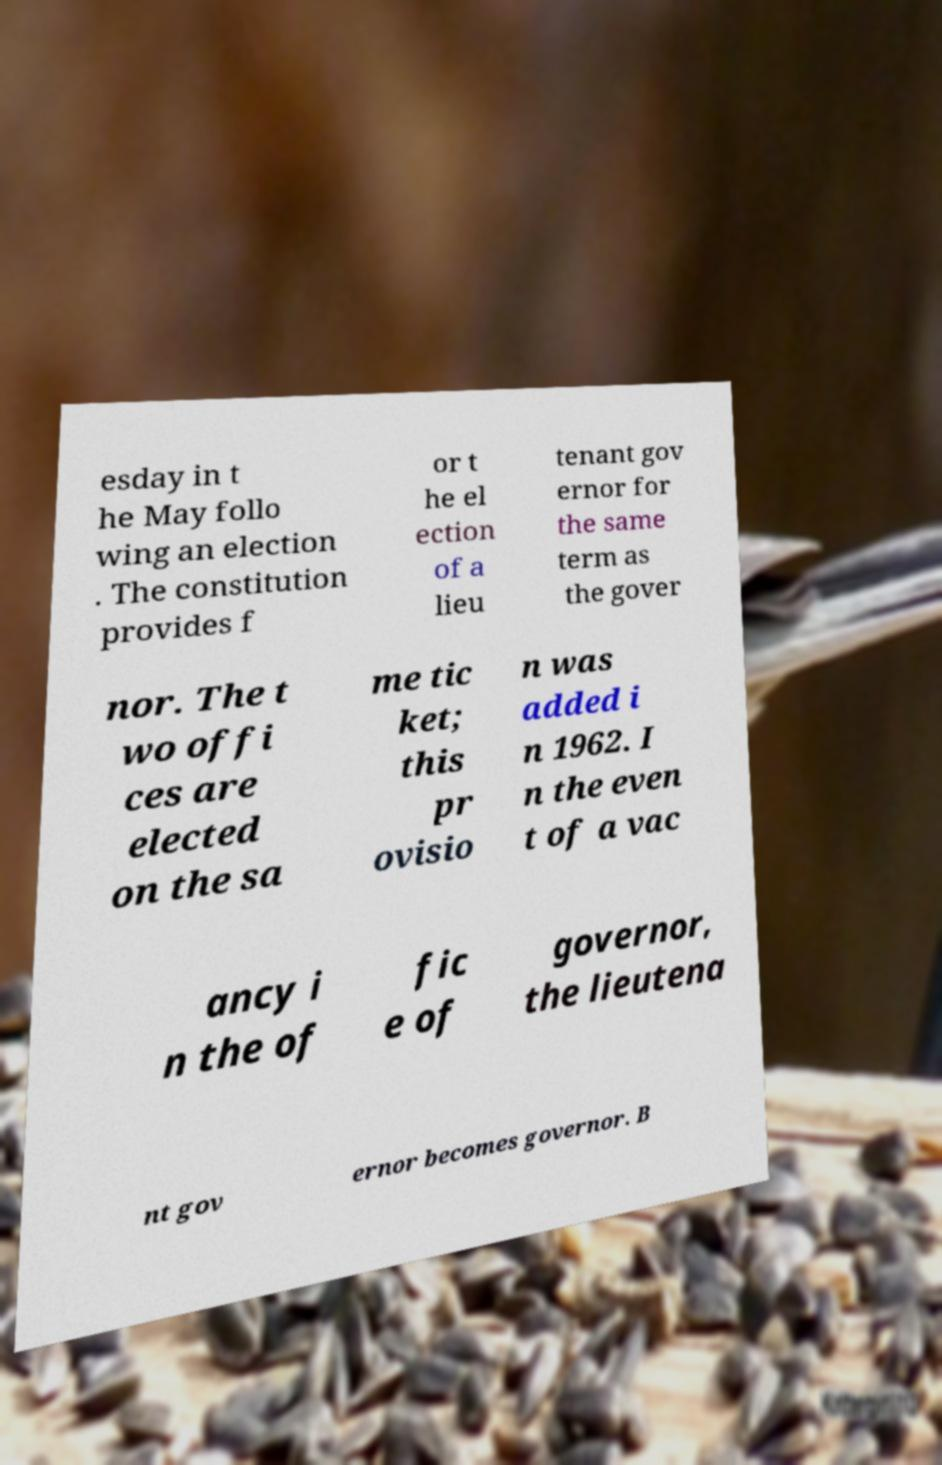Can you accurately transcribe the text from the provided image for me? esday in t he May follo wing an election . The constitution provides f or t he el ection of a lieu tenant gov ernor for the same term as the gover nor. The t wo offi ces are elected on the sa me tic ket; this pr ovisio n was added i n 1962. I n the even t of a vac ancy i n the of fic e of governor, the lieutena nt gov ernor becomes governor. B 